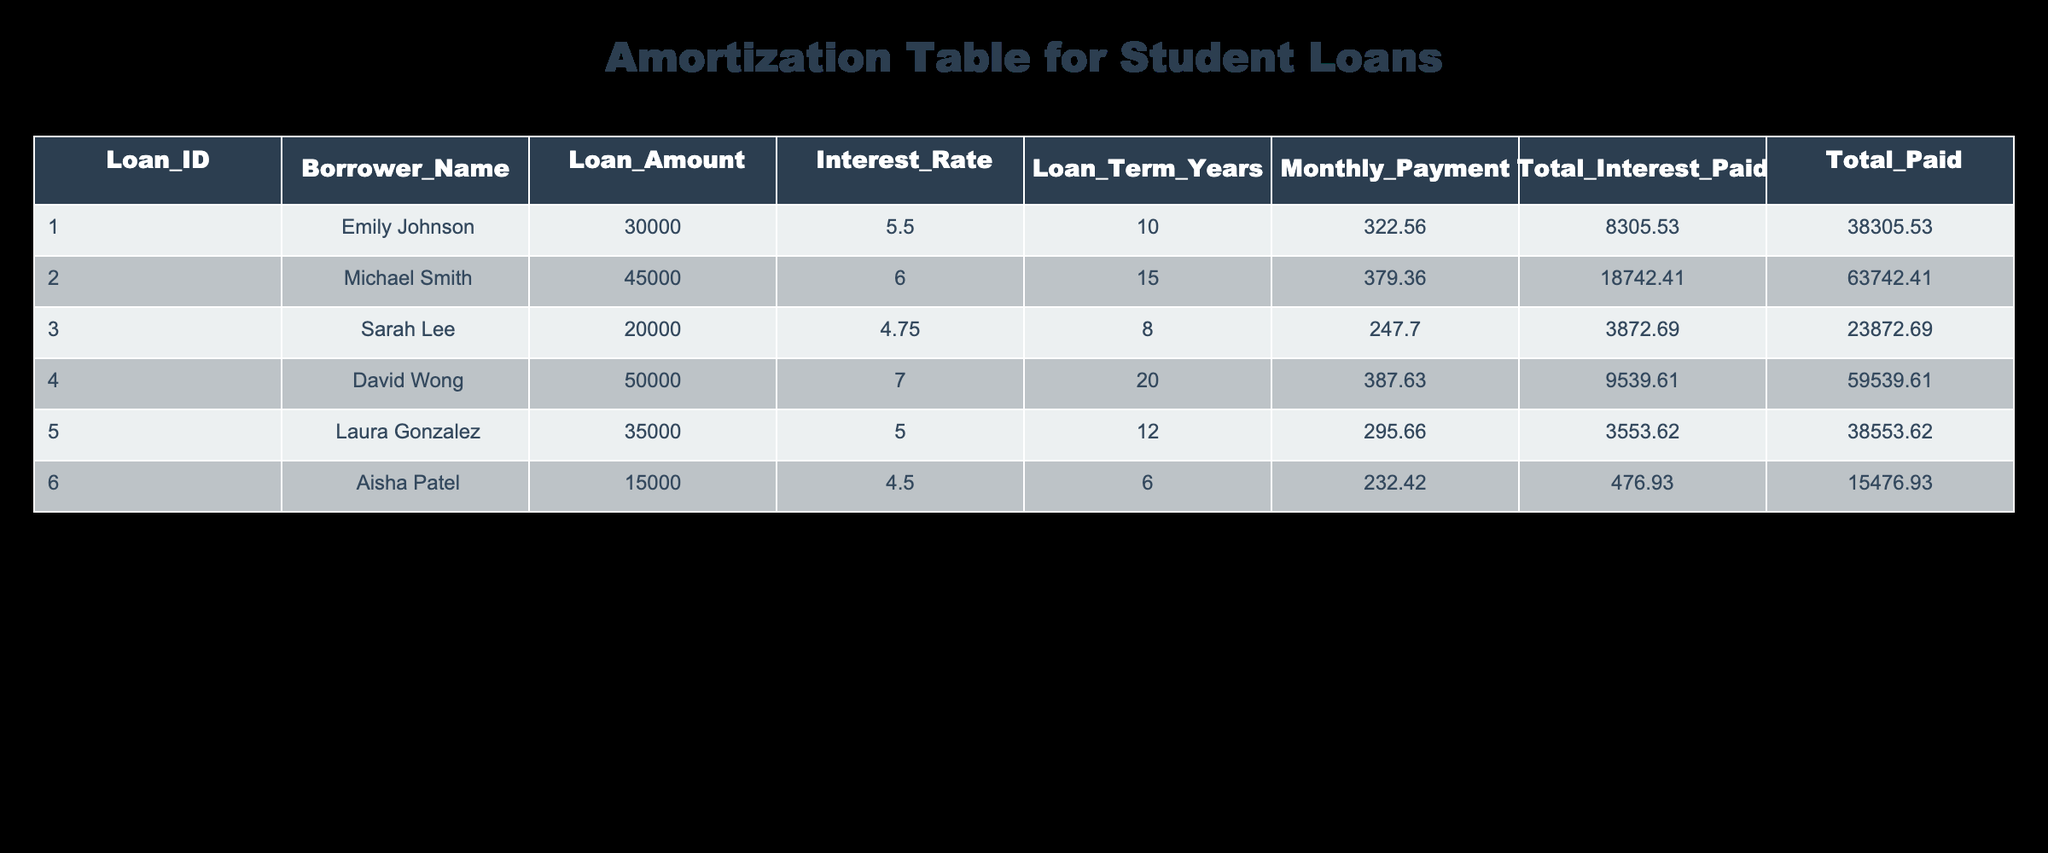What is the monthly payment for Emily Johnson's loan? Emily Johnson's loan amount is listed at 30,000 with a monthly payment of 322.56 in the table.
Answer: 322.56 Which borrower has the highest total amount paid including interest? In the table, Michael Smith's loan shows a total paid amount of 63,742.41, which is the largest compared to the other borrowers' total paid amounts.
Answer: Michael Smith What is the total interest paid by Sarah Lee? The table shows that Sarah Lee's total interest paid is 3,872.69, which can be directly retrieved from the appropriate cell in the table.
Answer: 3,872.69 Is Laura Gonzalez's interest rate higher than David Wong's? Laura Gonzalez's interest rate is 5.0, while David Wong's interest rate is 7.0. Since 5.0 is less than 7.0, the statement is false.
Answer: No What is the average total interest paid across all borrowers? To find the average total interest, we sum the total interest paid by all borrowers (8,305.53 + 18,742.41 + 3,872.69 + 9,539.61 + 3,553.62 + 476.93 = 44,490.79) and then divide by the number of borrowers (6). So the average is 44,490.79 / 6 = 7,415.13.
Answer: 7,415.13 Which loan has the shortest loan term and what is its monthly payment? Aisha Patel's loan has the shortest term of 6 years, and the corresponding monthly payment is 232.42, which can be seen in the table.
Answer: 232.42 What is the difference in total interest paid between Emily Johnson and David Wong? The total interest paid by Emily Johnson is 8,305.53, and by David Wong, it is 9,539.61. The difference is 9,539.61 - 8,305.53 = 1,234.08, calculated by subtracting the two values.
Answer: 1,234.08 Is it true that all borrowers have a loan amount greater than 10,000? By checking each loan amount in the table, all borrowers, including Aisha Patel with a loan amount of 15,000, exceed 10,000, confirming the statement as true.
Answer: Yes 